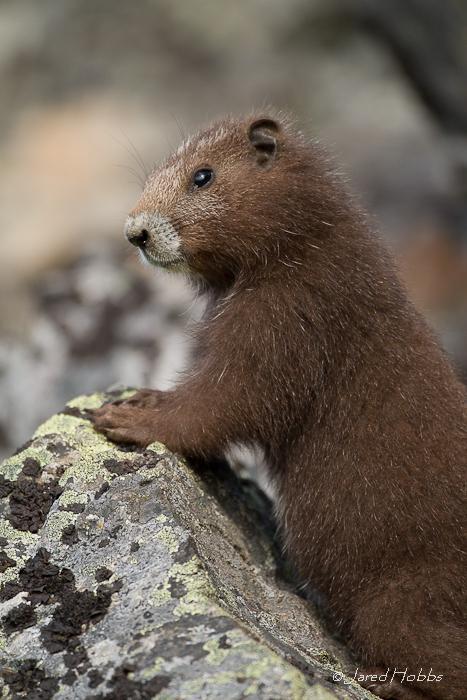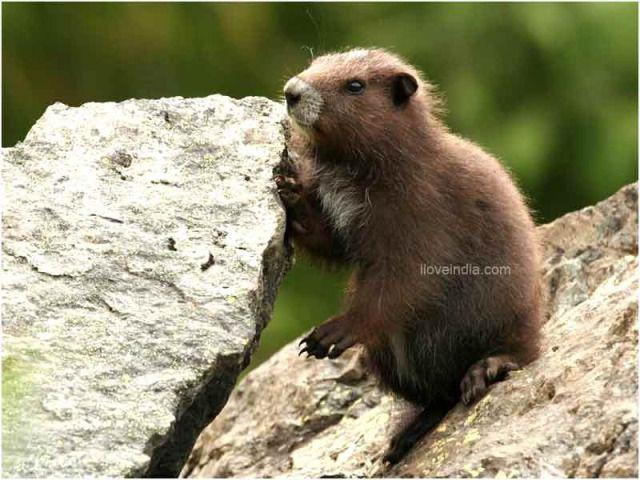The first image is the image on the left, the second image is the image on the right. Given the left and right images, does the statement "There are three marmots." hold true? Answer yes or no. No. The first image is the image on the left, the second image is the image on the right. Assess this claim about the two images: "One image shows two marmots posed face-to-face, and the other image shows one marmot on all fours on a rock.". Correct or not? Answer yes or no. No. 